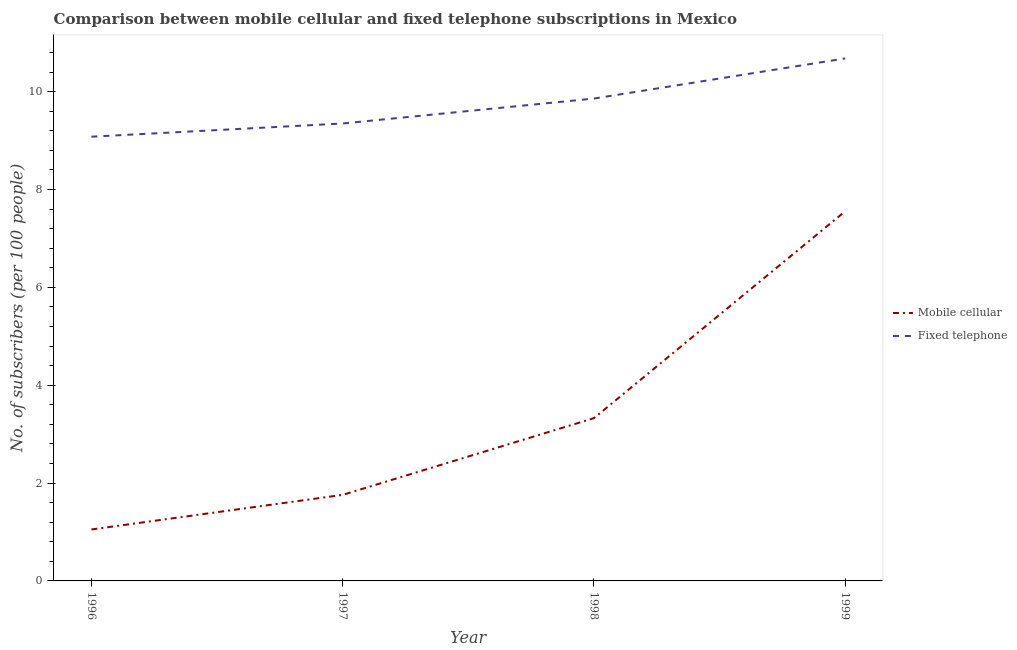How many different coloured lines are there?
Provide a short and direct response. 2. Does the line corresponding to number of mobile cellular subscribers intersect with the line corresponding to number of fixed telephone subscribers?
Your answer should be very brief. No. Is the number of lines equal to the number of legend labels?
Your answer should be compact. Yes. What is the number of fixed telephone subscribers in 1996?
Provide a succinct answer. 9.08. Across all years, what is the maximum number of fixed telephone subscribers?
Offer a very short reply. 10.68. Across all years, what is the minimum number of mobile cellular subscribers?
Your answer should be compact. 1.05. In which year was the number of fixed telephone subscribers minimum?
Make the answer very short. 1996. What is the total number of mobile cellular subscribers in the graph?
Your response must be concise. 13.69. What is the difference between the number of fixed telephone subscribers in 1996 and that in 1999?
Ensure brevity in your answer.  -1.6. What is the difference between the number of mobile cellular subscribers in 1998 and the number of fixed telephone subscribers in 1997?
Provide a short and direct response. -6.02. What is the average number of mobile cellular subscribers per year?
Keep it short and to the point. 3.42. In the year 1996, what is the difference between the number of fixed telephone subscribers and number of mobile cellular subscribers?
Your answer should be very brief. 8.03. What is the ratio of the number of mobile cellular subscribers in 1996 to that in 1998?
Keep it short and to the point. 0.32. Is the difference between the number of fixed telephone subscribers in 1998 and 1999 greater than the difference between the number of mobile cellular subscribers in 1998 and 1999?
Make the answer very short. Yes. What is the difference between the highest and the second highest number of fixed telephone subscribers?
Keep it short and to the point. 0.82. What is the difference between the highest and the lowest number of mobile cellular subscribers?
Ensure brevity in your answer.  6.51. Does the number of fixed telephone subscribers monotonically increase over the years?
Your answer should be compact. Yes. How many years are there in the graph?
Provide a succinct answer. 4. Are the values on the major ticks of Y-axis written in scientific E-notation?
Ensure brevity in your answer.  No. Does the graph contain any zero values?
Your response must be concise. No. Does the graph contain grids?
Keep it short and to the point. No. Where does the legend appear in the graph?
Keep it short and to the point. Center right. What is the title of the graph?
Your answer should be very brief. Comparison between mobile cellular and fixed telephone subscriptions in Mexico. What is the label or title of the X-axis?
Offer a very short reply. Year. What is the label or title of the Y-axis?
Your response must be concise. No. of subscribers (per 100 people). What is the No. of subscribers (per 100 people) in Mobile cellular in 1996?
Offer a very short reply. 1.05. What is the No. of subscribers (per 100 people) in Fixed telephone in 1996?
Give a very brief answer. 9.08. What is the No. of subscribers (per 100 people) of Mobile cellular in 1997?
Provide a short and direct response. 1.76. What is the No. of subscribers (per 100 people) of Fixed telephone in 1997?
Offer a very short reply. 9.35. What is the No. of subscribers (per 100 people) in Mobile cellular in 1998?
Provide a short and direct response. 3.33. What is the No. of subscribers (per 100 people) of Fixed telephone in 1998?
Your answer should be compact. 9.86. What is the No. of subscribers (per 100 people) in Mobile cellular in 1999?
Ensure brevity in your answer.  7.56. What is the No. of subscribers (per 100 people) in Fixed telephone in 1999?
Offer a terse response. 10.68. Across all years, what is the maximum No. of subscribers (per 100 people) of Mobile cellular?
Your response must be concise. 7.56. Across all years, what is the maximum No. of subscribers (per 100 people) of Fixed telephone?
Your answer should be compact. 10.68. Across all years, what is the minimum No. of subscribers (per 100 people) of Mobile cellular?
Give a very brief answer. 1.05. Across all years, what is the minimum No. of subscribers (per 100 people) of Fixed telephone?
Give a very brief answer. 9.08. What is the total No. of subscribers (per 100 people) in Mobile cellular in the graph?
Give a very brief answer. 13.69. What is the total No. of subscribers (per 100 people) of Fixed telephone in the graph?
Offer a very short reply. 38.97. What is the difference between the No. of subscribers (per 100 people) in Mobile cellular in 1996 and that in 1997?
Provide a succinct answer. -0.71. What is the difference between the No. of subscribers (per 100 people) in Fixed telephone in 1996 and that in 1997?
Offer a very short reply. -0.27. What is the difference between the No. of subscribers (per 100 people) of Mobile cellular in 1996 and that in 1998?
Provide a succinct answer. -2.28. What is the difference between the No. of subscribers (per 100 people) in Fixed telephone in 1996 and that in 1998?
Provide a succinct answer. -0.78. What is the difference between the No. of subscribers (per 100 people) in Mobile cellular in 1996 and that in 1999?
Offer a very short reply. -6.51. What is the difference between the No. of subscribers (per 100 people) of Fixed telephone in 1996 and that in 1999?
Your response must be concise. -1.6. What is the difference between the No. of subscribers (per 100 people) in Mobile cellular in 1997 and that in 1998?
Ensure brevity in your answer.  -1.57. What is the difference between the No. of subscribers (per 100 people) in Fixed telephone in 1997 and that in 1998?
Your response must be concise. -0.51. What is the difference between the No. of subscribers (per 100 people) in Mobile cellular in 1997 and that in 1999?
Give a very brief answer. -5.8. What is the difference between the No. of subscribers (per 100 people) in Fixed telephone in 1997 and that in 1999?
Ensure brevity in your answer.  -1.33. What is the difference between the No. of subscribers (per 100 people) of Mobile cellular in 1998 and that in 1999?
Provide a succinct answer. -4.23. What is the difference between the No. of subscribers (per 100 people) in Fixed telephone in 1998 and that in 1999?
Offer a terse response. -0.82. What is the difference between the No. of subscribers (per 100 people) in Mobile cellular in 1996 and the No. of subscribers (per 100 people) in Fixed telephone in 1997?
Ensure brevity in your answer.  -8.3. What is the difference between the No. of subscribers (per 100 people) in Mobile cellular in 1996 and the No. of subscribers (per 100 people) in Fixed telephone in 1998?
Provide a succinct answer. -8.81. What is the difference between the No. of subscribers (per 100 people) in Mobile cellular in 1996 and the No. of subscribers (per 100 people) in Fixed telephone in 1999?
Your answer should be very brief. -9.63. What is the difference between the No. of subscribers (per 100 people) of Mobile cellular in 1997 and the No. of subscribers (per 100 people) of Fixed telephone in 1998?
Give a very brief answer. -8.1. What is the difference between the No. of subscribers (per 100 people) in Mobile cellular in 1997 and the No. of subscribers (per 100 people) in Fixed telephone in 1999?
Your answer should be very brief. -8.92. What is the difference between the No. of subscribers (per 100 people) of Mobile cellular in 1998 and the No. of subscribers (per 100 people) of Fixed telephone in 1999?
Give a very brief answer. -7.35. What is the average No. of subscribers (per 100 people) in Mobile cellular per year?
Offer a terse response. 3.42. What is the average No. of subscribers (per 100 people) of Fixed telephone per year?
Your response must be concise. 9.74. In the year 1996, what is the difference between the No. of subscribers (per 100 people) of Mobile cellular and No. of subscribers (per 100 people) of Fixed telephone?
Give a very brief answer. -8.03. In the year 1997, what is the difference between the No. of subscribers (per 100 people) of Mobile cellular and No. of subscribers (per 100 people) of Fixed telephone?
Your answer should be very brief. -7.59. In the year 1998, what is the difference between the No. of subscribers (per 100 people) in Mobile cellular and No. of subscribers (per 100 people) in Fixed telephone?
Give a very brief answer. -6.53. In the year 1999, what is the difference between the No. of subscribers (per 100 people) of Mobile cellular and No. of subscribers (per 100 people) of Fixed telephone?
Offer a very short reply. -3.12. What is the ratio of the No. of subscribers (per 100 people) of Mobile cellular in 1996 to that in 1997?
Offer a very short reply. 0.6. What is the ratio of the No. of subscribers (per 100 people) of Fixed telephone in 1996 to that in 1997?
Offer a terse response. 0.97. What is the ratio of the No. of subscribers (per 100 people) of Mobile cellular in 1996 to that in 1998?
Provide a succinct answer. 0.32. What is the ratio of the No. of subscribers (per 100 people) in Fixed telephone in 1996 to that in 1998?
Your response must be concise. 0.92. What is the ratio of the No. of subscribers (per 100 people) in Mobile cellular in 1996 to that in 1999?
Keep it short and to the point. 0.14. What is the ratio of the No. of subscribers (per 100 people) of Fixed telephone in 1996 to that in 1999?
Your response must be concise. 0.85. What is the ratio of the No. of subscribers (per 100 people) of Mobile cellular in 1997 to that in 1998?
Provide a short and direct response. 0.53. What is the ratio of the No. of subscribers (per 100 people) in Fixed telephone in 1997 to that in 1998?
Your answer should be very brief. 0.95. What is the ratio of the No. of subscribers (per 100 people) in Mobile cellular in 1997 to that in 1999?
Make the answer very short. 0.23. What is the ratio of the No. of subscribers (per 100 people) of Fixed telephone in 1997 to that in 1999?
Ensure brevity in your answer.  0.88. What is the ratio of the No. of subscribers (per 100 people) in Mobile cellular in 1998 to that in 1999?
Your response must be concise. 0.44. What is the ratio of the No. of subscribers (per 100 people) of Fixed telephone in 1998 to that in 1999?
Keep it short and to the point. 0.92. What is the difference between the highest and the second highest No. of subscribers (per 100 people) in Mobile cellular?
Keep it short and to the point. 4.23. What is the difference between the highest and the second highest No. of subscribers (per 100 people) of Fixed telephone?
Make the answer very short. 0.82. What is the difference between the highest and the lowest No. of subscribers (per 100 people) of Mobile cellular?
Make the answer very short. 6.51. What is the difference between the highest and the lowest No. of subscribers (per 100 people) in Fixed telephone?
Offer a very short reply. 1.6. 